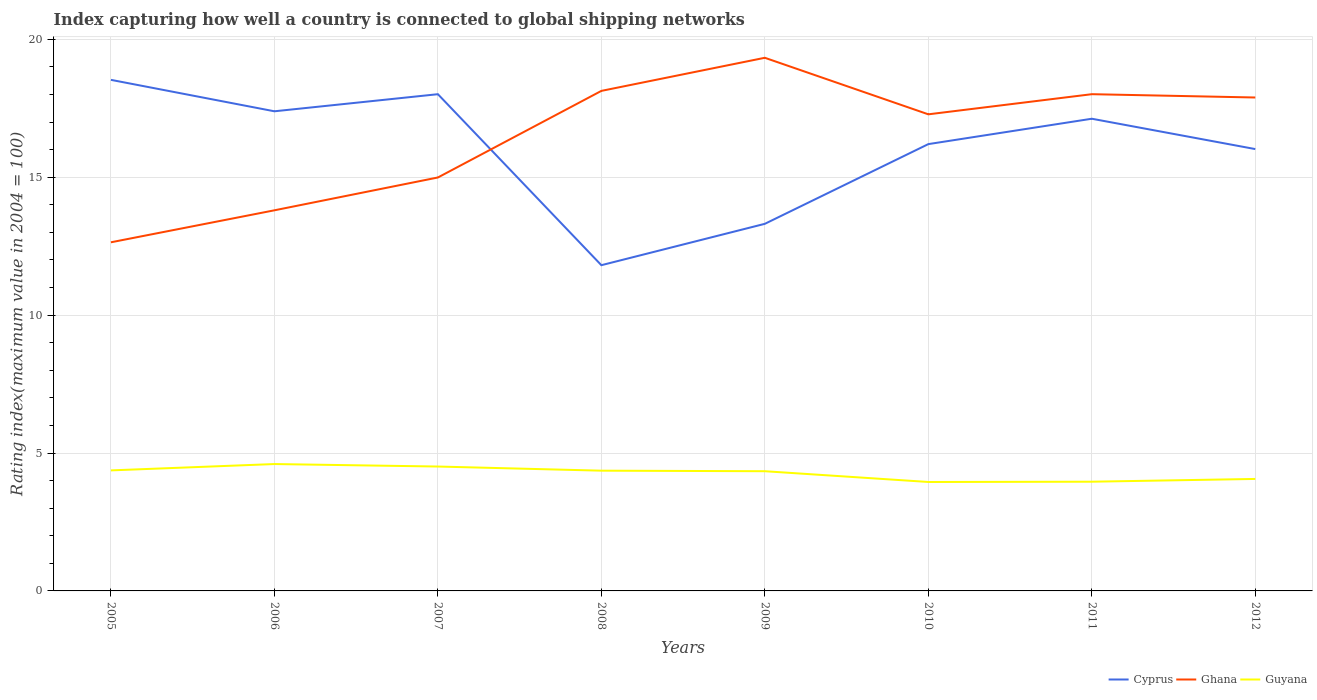How many different coloured lines are there?
Your response must be concise. 3. Does the line corresponding to Guyana intersect with the line corresponding to Ghana?
Give a very brief answer. No. Is the number of lines equal to the number of legend labels?
Your answer should be compact. Yes. Across all years, what is the maximum rating index in Ghana?
Give a very brief answer. 12.64. What is the total rating index in Cyprus in the graph?
Provide a succinct answer. 0.89. What is the difference between the highest and the second highest rating index in Cyprus?
Your response must be concise. 6.72. What is the difference between the highest and the lowest rating index in Guyana?
Your answer should be very brief. 5. How many lines are there?
Your answer should be compact. 3. What is the difference between two consecutive major ticks on the Y-axis?
Ensure brevity in your answer.  5. Are the values on the major ticks of Y-axis written in scientific E-notation?
Give a very brief answer. No. Does the graph contain grids?
Ensure brevity in your answer.  Yes. Where does the legend appear in the graph?
Your answer should be compact. Bottom right. How are the legend labels stacked?
Your answer should be compact. Horizontal. What is the title of the graph?
Your answer should be very brief. Index capturing how well a country is connected to global shipping networks. Does "Azerbaijan" appear as one of the legend labels in the graph?
Ensure brevity in your answer.  No. What is the label or title of the Y-axis?
Provide a succinct answer. Rating index(maximum value in 2004 = 100). What is the Rating index(maximum value in 2004 = 100) of Cyprus in 2005?
Keep it short and to the point. 18.53. What is the Rating index(maximum value in 2004 = 100) of Ghana in 2005?
Make the answer very short. 12.64. What is the Rating index(maximum value in 2004 = 100) in Guyana in 2005?
Make the answer very short. 4.37. What is the Rating index(maximum value in 2004 = 100) in Cyprus in 2006?
Make the answer very short. 17.39. What is the Rating index(maximum value in 2004 = 100) of Ghana in 2006?
Provide a short and direct response. 13.8. What is the Rating index(maximum value in 2004 = 100) of Cyprus in 2007?
Your answer should be very brief. 18.01. What is the Rating index(maximum value in 2004 = 100) in Ghana in 2007?
Give a very brief answer. 14.99. What is the Rating index(maximum value in 2004 = 100) in Guyana in 2007?
Your response must be concise. 4.51. What is the Rating index(maximum value in 2004 = 100) in Cyprus in 2008?
Your response must be concise. 11.81. What is the Rating index(maximum value in 2004 = 100) in Ghana in 2008?
Keep it short and to the point. 18.13. What is the Rating index(maximum value in 2004 = 100) of Guyana in 2008?
Provide a short and direct response. 4.36. What is the Rating index(maximum value in 2004 = 100) of Cyprus in 2009?
Offer a very short reply. 13.31. What is the Rating index(maximum value in 2004 = 100) of Ghana in 2009?
Keep it short and to the point. 19.33. What is the Rating index(maximum value in 2004 = 100) of Guyana in 2009?
Keep it short and to the point. 4.34. What is the Rating index(maximum value in 2004 = 100) in Ghana in 2010?
Your answer should be compact. 17.28. What is the Rating index(maximum value in 2004 = 100) of Guyana in 2010?
Give a very brief answer. 3.95. What is the Rating index(maximum value in 2004 = 100) in Cyprus in 2011?
Give a very brief answer. 17.12. What is the Rating index(maximum value in 2004 = 100) of Ghana in 2011?
Offer a terse response. 18.01. What is the Rating index(maximum value in 2004 = 100) of Guyana in 2011?
Keep it short and to the point. 3.96. What is the Rating index(maximum value in 2004 = 100) in Cyprus in 2012?
Your answer should be very brief. 16.02. What is the Rating index(maximum value in 2004 = 100) of Ghana in 2012?
Give a very brief answer. 17.89. What is the Rating index(maximum value in 2004 = 100) in Guyana in 2012?
Your answer should be very brief. 4.06. Across all years, what is the maximum Rating index(maximum value in 2004 = 100) in Cyprus?
Your answer should be compact. 18.53. Across all years, what is the maximum Rating index(maximum value in 2004 = 100) in Ghana?
Provide a short and direct response. 19.33. Across all years, what is the minimum Rating index(maximum value in 2004 = 100) in Cyprus?
Your answer should be compact. 11.81. Across all years, what is the minimum Rating index(maximum value in 2004 = 100) of Ghana?
Your answer should be compact. 12.64. Across all years, what is the minimum Rating index(maximum value in 2004 = 100) in Guyana?
Provide a short and direct response. 3.95. What is the total Rating index(maximum value in 2004 = 100) in Cyprus in the graph?
Offer a very short reply. 128.39. What is the total Rating index(maximum value in 2004 = 100) in Ghana in the graph?
Your answer should be compact. 132.07. What is the total Rating index(maximum value in 2004 = 100) of Guyana in the graph?
Ensure brevity in your answer.  34.15. What is the difference between the Rating index(maximum value in 2004 = 100) of Cyprus in 2005 and that in 2006?
Your answer should be compact. 1.14. What is the difference between the Rating index(maximum value in 2004 = 100) of Ghana in 2005 and that in 2006?
Your answer should be compact. -1.16. What is the difference between the Rating index(maximum value in 2004 = 100) in Guyana in 2005 and that in 2006?
Your response must be concise. -0.23. What is the difference between the Rating index(maximum value in 2004 = 100) in Cyprus in 2005 and that in 2007?
Give a very brief answer. 0.52. What is the difference between the Rating index(maximum value in 2004 = 100) in Ghana in 2005 and that in 2007?
Ensure brevity in your answer.  -2.35. What is the difference between the Rating index(maximum value in 2004 = 100) of Guyana in 2005 and that in 2007?
Keep it short and to the point. -0.14. What is the difference between the Rating index(maximum value in 2004 = 100) in Cyprus in 2005 and that in 2008?
Provide a short and direct response. 6.72. What is the difference between the Rating index(maximum value in 2004 = 100) in Ghana in 2005 and that in 2008?
Offer a very short reply. -5.49. What is the difference between the Rating index(maximum value in 2004 = 100) of Cyprus in 2005 and that in 2009?
Your answer should be very brief. 5.22. What is the difference between the Rating index(maximum value in 2004 = 100) in Ghana in 2005 and that in 2009?
Offer a very short reply. -6.69. What is the difference between the Rating index(maximum value in 2004 = 100) of Cyprus in 2005 and that in 2010?
Make the answer very short. 2.33. What is the difference between the Rating index(maximum value in 2004 = 100) of Ghana in 2005 and that in 2010?
Make the answer very short. -4.64. What is the difference between the Rating index(maximum value in 2004 = 100) of Guyana in 2005 and that in 2010?
Provide a short and direct response. 0.42. What is the difference between the Rating index(maximum value in 2004 = 100) in Cyprus in 2005 and that in 2011?
Your answer should be compact. 1.41. What is the difference between the Rating index(maximum value in 2004 = 100) in Ghana in 2005 and that in 2011?
Offer a terse response. -5.37. What is the difference between the Rating index(maximum value in 2004 = 100) of Guyana in 2005 and that in 2011?
Your response must be concise. 0.41. What is the difference between the Rating index(maximum value in 2004 = 100) in Cyprus in 2005 and that in 2012?
Make the answer very short. 2.51. What is the difference between the Rating index(maximum value in 2004 = 100) of Ghana in 2005 and that in 2012?
Keep it short and to the point. -5.25. What is the difference between the Rating index(maximum value in 2004 = 100) in Guyana in 2005 and that in 2012?
Provide a succinct answer. 0.31. What is the difference between the Rating index(maximum value in 2004 = 100) in Cyprus in 2006 and that in 2007?
Provide a succinct answer. -0.62. What is the difference between the Rating index(maximum value in 2004 = 100) in Ghana in 2006 and that in 2007?
Make the answer very short. -1.19. What is the difference between the Rating index(maximum value in 2004 = 100) in Guyana in 2006 and that in 2007?
Offer a very short reply. 0.09. What is the difference between the Rating index(maximum value in 2004 = 100) of Cyprus in 2006 and that in 2008?
Offer a terse response. 5.58. What is the difference between the Rating index(maximum value in 2004 = 100) of Ghana in 2006 and that in 2008?
Your response must be concise. -4.33. What is the difference between the Rating index(maximum value in 2004 = 100) in Guyana in 2006 and that in 2008?
Offer a very short reply. 0.24. What is the difference between the Rating index(maximum value in 2004 = 100) of Cyprus in 2006 and that in 2009?
Provide a short and direct response. 4.08. What is the difference between the Rating index(maximum value in 2004 = 100) in Ghana in 2006 and that in 2009?
Keep it short and to the point. -5.53. What is the difference between the Rating index(maximum value in 2004 = 100) in Guyana in 2006 and that in 2009?
Offer a very short reply. 0.26. What is the difference between the Rating index(maximum value in 2004 = 100) of Cyprus in 2006 and that in 2010?
Offer a very short reply. 1.19. What is the difference between the Rating index(maximum value in 2004 = 100) in Ghana in 2006 and that in 2010?
Provide a short and direct response. -3.48. What is the difference between the Rating index(maximum value in 2004 = 100) of Guyana in 2006 and that in 2010?
Offer a very short reply. 0.65. What is the difference between the Rating index(maximum value in 2004 = 100) of Cyprus in 2006 and that in 2011?
Your answer should be compact. 0.27. What is the difference between the Rating index(maximum value in 2004 = 100) of Ghana in 2006 and that in 2011?
Give a very brief answer. -4.21. What is the difference between the Rating index(maximum value in 2004 = 100) in Guyana in 2006 and that in 2011?
Offer a terse response. 0.64. What is the difference between the Rating index(maximum value in 2004 = 100) of Cyprus in 2006 and that in 2012?
Provide a short and direct response. 1.37. What is the difference between the Rating index(maximum value in 2004 = 100) in Ghana in 2006 and that in 2012?
Provide a short and direct response. -4.09. What is the difference between the Rating index(maximum value in 2004 = 100) of Guyana in 2006 and that in 2012?
Keep it short and to the point. 0.54. What is the difference between the Rating index(maximum value in 2004 = 100) of Ghana in 2007 and that in 2008?
Keep it short and to the point. -3.14. What is the difference between the Rating index(maximum value in 2004 = 100) of Cyprus in 2007 and that in 2009?
Keep it short and to the point. 4.7. What is the difference between the Rating index(maximum value in 2004 = 100) in Ghana in 2007 and that in 2009?
Your answer should be compact. -4.34. What is the difference between the Rating index(maximum value in 2004 = 100) in Guyana in 2007 and that in 2009?
Provide a succinct answer. 0.17. What is the difference between the Rating index(maximum value in 2004 = 100) of Cyprus in 2007 and that in 2010?
Make the answer very short. 1.81. What is the difference between the Rating index(maximum value in 2004 = 100) in Ghana in 2007 and that in 2010?
Your answer should be compact. -2.29. What is the difference between the Rating index(maximum value in 2004 = 100) of Guyana in 2007 and that in 2010?
Your answer should be very brief. 0.56. What is the difference between the Rating index(maximum value in 2004 = 100) of Cyprus in 2007 and that in 2011?
Make the answer very short. 0.89. What is the difference between the Rating index(maximum value in 2004 = 100) of Ghana in 2007 and that in 2011?
Ensure brevity in your answer.  -3.02. What is the difference between the Rating index(maximum value in 2004 = 100) of Guyana in 2007 and that in 2011?
Offer a very short reply. 0.55. What is the difference between the Rating index(maximum value in 2004 = 100) of Cyprus in 2007 and that in 2012?
Offer a terse response. 1.99. What is the difference between the Rating index(maximum value in 2004 = 100) in Ghana in 2007 and that in 2012?
Provide a short and direct response. -2.9. What is the difference between the Rating index(maximum value in 2004 = 100) in Guyana in 2007 and that in 2012?
Your answer should be very brief. 0.45. What is the difference between the Rating index(maximum value in 2004 = 100) in Guyana in 2008 and that in 2009?
Provide a succinct answer. 0.02. What is the difference between the Rating index(maximum value in 2004 = 100) of Cyprus in 2008 and that in 2010?
Keep it short and to the point. -4.39. What is the difference between the Rating index(maximum value in 2004 = 100) of Ghana in 2008 and that in 2010?
Give a very brief answer. 0.85. What is the difference between the Rating index(maximum value in 2004 = 100) of Guyana in 2008 and that in 2010?
Give a very brief answer. 0.41. What is the difference between the Rating index(maximum value in 2004 = 100) of Cyprus in 2008 and that in 2011?
Ensure brevity in your answer.  -5.31. What is the difference between the Rating index(maximum value in 2004 = 100) in Ghana in 2008 and that in 2011?
Provide a succinct answer. 0.12. What is the difference between the Rating index(maximum value in 2004 = 100) of Cyprus in 2008 and that in 2012?
Your answer should be compact. -4.21. What is the difference between the Rating index(maximum value in 2004 = 100) in Ghana in 2008 and that in 2012?
Provide a succinct answer. 0.24. What is the difference between the Rating index(maximum value in 2004 = 100) of Cyprus in 2009 and that in 2010?
Offer a terse response. -2.89. What is the difference between the Rating index(maximum value in 2004 = 100) of Ghana in 2009 and that in 2010?
Make the answer very short. 2.05. What is the difference between the Rating index(maximum value in 2004 = 100) of Guyana in 2009 and that in 2010?
Offer a very short reply. 0.39. What is the difference between the Rating index(maximum value in 2004 = 100) of Cyprus in 2009 and that in 2011?
Offer a very short reply. -3.81. What is the difference between the Rating index(maximum value in 2004 = 100) of Ghana in 2009 and that in 2011?
Provide a succinct answer. 1.32. What is the difference between the Rating index(maximum value in 2004 = 100) in Guyana in 2009 and that in 2011?
Offer a terse response. 0.38. What is the difference between the Rating index(maximum value in 2004 = 100) in Cyprus in 2009 and that in 2012?
Ensure brevity in your answer.  -2.71. What is the difference between the Rating index(maximum value in 2004 = 100) of Ghana in 2009 and that in 2012?
Your answer should be very brief. 1.44. What is the difference between the Rating index(maximum value in 2004 = 100) of Guyana in 2009 and that in 2012?
Give a very brief answer. 0.28. What is the difference between the Rating index(maximum value in 2004 = 100) of Cyprus in 2010 and that in 2011?
Your answer should be compact. -0.92. What is the difference between the Rating index(maximum value in 2004 = 100) in Ghana in 2010 and that in 2011?
Provide a short and direct response. -0.73. What is the difference between the Rating index(maximum value in 2004 = 100) of Guyana in 2010 and that in 2011?
Offer a terse response. -0.01. What is the difference between the Rating index(maximum value in 2004 = 100) in Cyprus in 2010 and that in 2012?
Your answer should be very brief. 0.18. What is the difference between the Rating index(maximum value in 2004 = 100) of Ghana in 2010 and that in 2012?
Provide a short and direct response. -0.61. What is the difference between the Rating index(maximum value in 2004 = 100) of Guyana in 2010 and that in 2012?
Your response must be concise. -0.11. What is the difference between the Rating index(maximum value in 2004 = 100) of Ghana in 2011 and that in 2012?
Your answer should be compact. 0.12. What is the difference between the Rating index(maximum value in 2004 = 100) in Guyana in 2011 and that in 2012?
Offer a very short reply. -0.1. What is the difference between the Rating index(maximum value in 2004 = 100) of Cyprus in 2005 and the Rating index(maximum value in 2004 = 100) of Ghana in 2006?
Make the answer very short. 4.73. What is the difference between the Rating index(maximum value in 2004 = 100) in Cyprus in 2005 and the Rating index(maximum value in 2004 = 100) in Guyana in 2006?
Make the answer very short. 13.93. What is the difference between the Rating index(maximum value in 2004 = 100) of Ghana in 2005 and the Rating index(maximum value in 2004 = 100) of Guyana in 2006?
Provide a short and direct response. 8.04. What is the difference between the Rating index(maximum value in 2004 = 100) of Cyprus in 2005 and the Rating index(maximum value in 2004 = 100) of Ghana in 2007?
Give a very brief answer. 3.54. What is the difference between the Rating index(maximum value in 2004 = 100) of Cyprus in 2005 and the Rating index(maximum value in 2004 = 100) of Guyana in 2007?
Provide a short and direct response. 14.02. What is the difference between the Rating index(maximum value in 2004 = 100) of Ghana in 2005 and the Rating index(maximum value in 2004 = 100) of Guyana in 2007?
Keep it short and to the point. 8.13. What is the difference between the Rating index(maximum value in 2004 = 100) in Cyprus in 2005 and the Rating index(maximum value in 2004 = 100) in Ghana in 2008?
Give a very brief answer. 0.4. What is the difference between the Rating index(maximum value in 2004 = 100) of Cyprus in 2005 and the Rating index(maximum value in 2004 = 100) of Guyana in 2008?
Your answer should be compact. 14.17. What is the difference between the Rating index(maximum value in 2004 = 100) in Ghana in 2005 and the Rating index(maximum value in 2004 = 100) in Guyana in 2008?
Offer a very short reply. 8.28. What is the difference between the Rating index(maximum value in 2004 = 100) in Cyprus in 2005 and the Rating index(maximum value in 2004 = 100) in Ghana in 2009?
Your response must be concise. -0.8. What is the difference between the Rating index(maximum value in 2004 = 100) of Cyprus in 2005 and the Rating index(maximum value in 2004 = 100) of Guyana in 2009?
Make the answer very short. 14.19. What is the difference between the Rating index(maximum value in 2004 = 100) in Ghana in 2005 and the Rating index(maximum value in 2004 = 100) in Guyana in 2009?
Your answer should be compact. 8.3. What is the difference between the Rating index(maximum value in 2004 = 100) in Cyprus in 2005 and the Rating index(maximum value in 2004 = 100) in Guyana in 2010?
Offer a terse response. 14.58. What is the difference between the Rating index(maximum value in 2004 = 100) of Ghana in 2005 and the Rating index(maximum value in 2004 = 100) of Guyana in 2010?
Provide a succinct answer. 8.69. What is the difference between the Rating index(maximum value in 2004 = 100) in Cyprus in 2005 and the Rating index(maximum value in 2004 = 100) in Ghana in 2011?
Ensure brevity in your answer.  0.52. What is the difference between the Rating index(maximum value in 2004 = 100) in Cyprus in 2005 and the Rating index(maximum value in 2004 = 100) in Guyana in 2011?
Provide a short and direct response. 14.57. What is the difference between the Rating index(maximum value in 2004 = 100) in Ghana in 2005 and the Rating index(maximum value in 2004 = 100) in Guyana in 2011?
Ensure brevity in your answer.  8.68. What is the difference between the Rating index(maximum value in 2004 = 100) in Cyprus in 2005 and the Rating index(maximum value in 2004 = 100) in Ghana in 2012?
Give a very brief answer. 0.64. What is the difference between the Rating index(maximum value in 2004 = 100) of Cyprus in 2005 and the Rating index(maximum value in 2004 = 100) of Guyana in 2012?
Provide a short and direct response. 14.47. What is the difference between the Rating index(maximum value in 2004 = 100) in Ghana in 2005 and the Rating index(maximum value in 2004 = 100) in Guyana in 2012?
Your response must be concise. 8.58. What is the difference between the Rating index(maximum value in 2004 = 100) of Cyprus in 2006 and the Rating index(maximum value in 2004 = 100) of Guyana in 2007?
Provide a short and direct response. 12.88. What is the difference between the Rating index(maximum value in 2004 = 100) of Ghana in 2006 and the Rating index(maximum value in 2004 = 100) of Guyana in 2007?
Your answer should be very brief. 9.29. What is the difference between the Rating index(maximum value in 2004 = 100) in Cyprus in 2006 and the Rating index(maximum value in 2004 = 100) in Ghana in 2008?
Your response must be concise. -0.74. What is the difference between the Rating index(maximum value in 2004 = 100) of Cyprus in 2006 and the Rating index(maximum value in 2004 = 100) of Guyana in 2008?
Offer a terse response. 13.03. What is the difference between the Rating index(maximum value in 2004 = 100) in Ghana in 2006 and the Rating index(maximum value in 2004 = 100) in Guyana in 2008?
Offer a terse response. 9.44. What is the difference between the Rating index(maximum value in 2004 = 100) in Cyprus in 2006 and the Rating index(maximum value in 2004 = 100) in Ghana in 2009?
Provide a short and direct response. -1.94. What is the difference between the Rating index(maximum value in 2004 = 100) in Cyprus in 2006 and the Rating index(maximum value in 2004 = 100) in Guyana in 2009?
Give a very brief answer. 13.05. What is the difference between the Rating index(maximum value in 2004 = 100) in Ghana in 2006 and the Rating index(maximum value in 2004 = 100) in Guyana in 2009?
Make the answer very short. 9.46. What is the difference between the Rating index(maximum value in 2004 = 100) in Cyprus in 2006 and the Rating index(maximum value in 2004 = 100) in Ghana in 2010?
Your answer should be compact. 0.11. What is the difference between the Rating index(maximum value in 2004 = 100) in Cyprus in 2006 and the Rating index(maximum value in 2004 = 100) in Guyana in 2010?
Make the answer very short. 13.44. What is the difference between the Rating index(maximum value in 2004 = 100) in Ghana in 2006 and the Rating index(maximum value in 2004 = 100) in Guyana in 2010?
Keep it short and to the point. 9.85. What is the difference between the Rating index(maximum value in 2004 = 100) of Cyprus in 2006 and the Rating index(maximum value in 2004 = 100) of Ghana in 2011?
Provide a short and direct response. -0.62. What is the difference between the Rating index(maximum value in 2004 = 100) of Cyprus in 2006 and the Rating index(maximum value in 2004 = 100) of Guyana in 2011?
Provide a short and direct response. 13.43. What is the difference between the Rating index(maximum value in 2004 = 100) in Ghana in 2006 and the Rating index(maximum value in 2004 = 100) in Guyana in 2011?
Ensure brevity in your answer.  9.84. What is the difference between the Rating index(maximum value in 2004 = 100) in Cyprus in 2006 and the Rating index(maximum value in 2004 = 100) in Ghana in 2012?
Provide a short and direct response. -0.5. What is the difference between the Rating index(maximum value in 2004 = 100) in Cyprus in 2006 and the Rating index(maximum value in 2004 = 100) in Guyana in 2012?
Provide a succinct answer. 13.33. What is the difference between the Rating index(maximum value in 2004 = 100) of Ghana in 2006 and the Rating index(maximum value in 2004 = 100) of Guyana in 2012?
Ensure brevity in your answer.  9.74. What is the difference between the Rating index(maximum value in 2004 = 100) in Cyprus in 2007 and the Rating index(maximum value in 2004 = 100) in Ghana in 2008?
Offer a terse response. -0.12. What is the difference between the Rating index(maximum value in 2004 = 100) of Cyprus in 2007 and the Rating index(maximum value in 2004 = 100) of Guyana in 2008?
Offer a very short reply. 13.65. What is the difference between the Rating index(maximum value in 2004 = 100) in Ghana in 2007 and the Rating index(maximum value in 2004 = 100) in Guyana in 2008?
Ensure brevity in your answer.  10.63. What is the difference between the Rating index(maximum value in 2004 = 100) in Cyprus in 2007 and the Rating index(maximum value in 2004 = 100) in Ghana in 2009?
Keep it short and to the point. -1.32. What is the difference between the Rating index(maximum value in 2004 = 100) in Cyprus in 2007 and the Rating index(maximum value in 2004 = 100) in Guyana in 2009?
Make the answer very short. 13.67. What is the difference between the Rating index(maximum value in 2004 = 100) in Ghana in 2007 and the Rating index(maximum value in 2004 = 100) in Guyana in 2009?
Ensure brevity in your answer.  10.65. What is the difference between the Rating index(maximum value in 2004 = 100) in Cyprus in 2007 and the Rating index(maximum value in 2004 = 100) in Ghana in 2010?
Offer a very short reply. 0.73. What is the difference between the Rating index(maximum value in 2004 = 100) of Cyprus in 2007 and the Rating index(maximum value in 2004 = 100) of Guyana in 2010?
Your response must be concise. 14.06. What is the difference between the Rating index(maximum value in 2004 = 100) in Ghana in 2007 and the Rating index(maximum value in 2004 = 100) in Guyana in 2010?
Provide a short and direct response. 11.04. What is the difference between the Rating index(maximum value in 2004 = 100) in Cyprus in 2007 and the Rating index(maximum value in 2004 = 100) in Guyana in 2011?
Provide a short and direct response. 14.05. What is the difference between the Rating index(maximum value in 2004 = 100) of Ghana in 2007 and the Rating index(maximum value in 2004 = 100) of Guyana in 2011?
Ensure brevity in your answer.  11.03. What is the difference between the Rating index(maximum value in 2004 = 100) of Cyprus in 2007 and the Rating index(maximum value in 2004 = 100) of Ghana in 2012?
Ensure brevity in your answer.  0.12. What is the difference between the Rating index(maximum value in 2004 = 100) of Cyprus in 2007 and the Rating index(maximum value in 2004 = 100) of Guyana in 2012?
Your response must be concise. 13.95. What is the difference between the Rating index(maximum value in 2004 = 100) in Ghana in 2007 and the Rating index(maximum value in 2004 = 100) in Guyana in 2012?
Your answer should be very brief. 10.93. What is the difference between the Rating index(maximum value in 2004 = 100) of Cyprus in 2008 and the Rating index(maximum value in 2004 = 100) of Ghana in 2009?
Your answer should be compact. -7.52. What is the difference between the Rating index(maximum value in 2004 = 100) of Cyprus in 2008 and the Rating index(maximum value in 2004 = 100) of Guyana in 2009?
Offer a very short reply. 7.47. What is the difference between the Rating index(maximum value in 2004 = 100) of Ghana in 2008 and the Rating index(maximum value in 2004 = 100) of Guyana in 2009?
Offer a terse response. 13.79. What is the difference between the Rating index(maximum value in 2004 = 100) of Cyprus in 2008 and the Rating index(maximum value in 2004 = 100) of Ghana in 2010?
Keep it short and to the point. -5.47. What is the difference between the Rating index(maximum value in 2004 = 100) in Cyprus in 2008 and the Rating index(maximum value in 2004 = 100) in Guyana in 2010?
Keep it short and to the point. 7.86. What is the difference between the Rating index(maximum value in 2004 = 100) in Ghana in 2008 and the Rating index(maximum value in 2004 = 100) in Guyana in 2010?
Ensure brevity in your answer.  14.18. What is the difference between the Rating index(maximum value in 2004 = 100) in Cyprus in 2008 and the Rating index(maximum value in 2004 = 100) in Ghana in 2011?
Your response must be concise. -6.2. What is the difference between the Rating index(maximum value in 2004 = 100) in Cyprus in 2008 and the Rating index(maximum value in 2004 = 100) in Guyana in 2011?
Your answer should be compact. 7.85. What is the difference between the Rating index(maximum value in 2004 = 100) of Ghana in 2008 and the Rating index(maximum value in 2004 = 100) of Guyana in 2011?
Your answer should be very brief. 14.17. What is the difference between the Rating index(maximum value in 2004 = 100) of Cyprus in 2008 and the Rating index(maximum value in 2004 = 100) of Ghana in 2012?
Your answer should be compact. -6.08. What is the difference between the Rating index(maximum value in 2004 = 100) of Cyprus in 2008 and the Rating index(maximum value in 2004 = 100) of Guyana in 2012?
Provide a short and direct response. 7.75. What is the difference between the Rating index(maximum value in 2004 = 100) in Ghana in 2008 and the Rating index(maximum value in 2004 = 100) in Guyana in 2012?
Provide a short and direct response. 14.07. What is the difference between the Rating index(maximum value in 2004 = 100) in Cyprus in 2009 and the Rating index(maximum value in 2004 = 100) in Ghana in 2010?
Your response must be concise. -3.97. What is the difference between the Rating index(maximum value in 2004 = 100) in Cyprus in 2009 and the Rating index(maximum value in 2004 = 100) in Guyana in 2010?
Give a very brief answer. 9.36. What is the difference between the Rating index(maximum value in 2004 = 100) of Ghana in 2009 and the Rating index(maximum value in 2004 = 100) of Guyana in 2010?
Offer a terse response. 15.38. What is the difference between the Rating index(maximum value in 2004 = 100) of Cyprus in 2009 and the Rating index(maximum value in 2004 = 100) of Ghana in 2011?
Keep it short and to the point. -4.7. What is the difference between the Rating index(maximum value in 2004 = 100) of Cyprus in 2009 and the Rating index(maximum value in 2004 = 100) of Guyana in 2011?
Keep it short and to the point. 9.35. What is the difference between the Rating index(maximum value in 2004 = 100) of Ghana in 2009 and the Rating index(maximum value in 2004 = 100) of Guyana in 2011?
Ensure brevity in your answer.  15.37. What is the difference between the Rating index(maximum value in 2004 = 100) of Cyprus in 2009 and the Rating index(maximum value in 2004 = 100) of Ghana in 2012?
Your answer should be compact. -4.58. What is the difference between the Rating index(maximum value in 2004 = 100) of Cyprus in 2009 and the Rating index(maximum value in 2004 = 100) of Guyana in 2012?
Ensure brevity in your answer.  9.25. What is the difference between the Rating index(maximum value in 2004 = 100) of Ghana in 2009 and the Rating index(maximum value in 2004 = 100) of Guyana in 2012?
Offer a very short reply. 15.27. What is the difference between the Rating index(maximum value in 2004 = 100) in Cyprus in 2010 and the Rating index(maximum value in 2004 = 100) in Ghana in 2011?
Your answer should be compact. -1.81. What is the difference between the Rating index(maximum value in 2004 = 100) of Cyprus in 2010 and the Rating index(maximum value in 2004 = 100) of Guyana in 2011?
Give a very brief answer. 12.24. What is the difference between the Rating index(maximum value in 2004 = 100) in Ghana in 2010 and the Rating index(maximum value in 2004 = 100) in Guyana in 2011?
Keep it short and to the point. 13.32. What is the difference between the Rating index(maximum value in 2004 = 100) in Cyprus in 2010 and the Rating index(maximum value in 2004 = 100) in Ghana in 2012?
Your answer should be compact. -1.69. What is the difference between the Rating index(maximum value in 2004 = 100) in Cyprus in 2010 and the Rating index(maximum value in 2004 = 100) in Guyana in 2012?
Make the answer very short. 12.14. What is the difference between the Rating index(maximum value in 2004 = 100) of Ghana in 2010 and the Rating index(maximum value in 2004 = 100) of Guyana in 2012?
Ensure brevity in your answer.  13.22. What is the difference between the Rating index(maximum value in 2004 = 100) of Cyprus in 2011 and the Rating index(maximum value in 2004 = 100) of Ghana in 2012?
Offer a terse response. -0.77. What is the difference between the Rating index(maximum value in 2004 = 100) of Cyprus in 2011 and the Rating index(maximum value in 2004 = 100) of Guyana in 2012?
Offer a terse response. 13.06. What is the difference between the Rating index(maximum value in 2004 = 100) in Ghana in 2011 and the Rating index(maximum value in 2004 = 100) in Guyana in 2012?
Your answer should be very brief. 13.95. What is the average Rating index(maximum value in 2004 = 100) in Cyprus per year?
Provide a succinct answer. 16.05. What is the average Rating index(maximum value in 2004 = 100) in Ghana per year?
Make the answer very short. 16.51. What is the average Rating index(maximum value in 2004 = 100) in Guyana per year?
Give a very brief answer. 4.27. In the year 2005, what is the difference between the Rating index(maximum value in 2004 = 100) in Cyprus and Rating index(maximum value in 2004 = 100) in Ghana?
Your response must be concise. 5.89. In the year 2005, what is the difference between the Rating index(maximum value in 2004 = 100) of Cyprus and Rating index(maximum value in 2004 = 100) of Guyana?
Your answer should be compact. 14.16. In the year 2005, what is the difference between the Rating index(maximum value in 2004 = 100) of Ghana and Rating index(maximum value in 2004 = 100) of Guyana?
Your answer should be compact. 8.27. In the year 2006, what is the difference between the Rating index(maximum value in 2004 = 100) in Cyprus and Rating index(maximum value in 2004 = 100) in Ghana?
Your response must be concise. 3.59. In the year 2006, what is the difference between the Rating index(maximum value in 2004 = 100) of Cyprus and Rating index(maximum value in 2004 = 100) of Guyana?
Provide a succinct answer. 12.79. In the year 2007, what is the difference between the Rating index(maximum value in 2004 = 100) in Cyprus and Rating index(maximum value in 2004 = 100) in Ghana?
Offer a terse response. 3.02. In the year 2007, what is the difference between the Rating index(maximum value in 2004 = 100) in Cyprus and Rating index(maximum value in 2004 = 100) in Guyana?
Your response must be concise. 13.5. In the year 2007, what is the difference between the Rating index(maximum value in 2004 = 100) of Ghana and Rating index(maximum value in 2004 = 100) of Guyana?
Make the answer very short. 10.48. In the year 2008, what is the difference between the Rating index(maximum value in 2004 = 100) in Cyprus and Rating index(maximum value in 2004 = 100) in Ghana?
Your answer should be very brief. -6.32. In the year 2008, what is the difference between the Rating index(maximum value in 2004 = 100) in Cyprus and Rating index(maximum value in 2004 = 100) in Guyana?
Keep it short and to the point. 7.45. In the year 2008, what is the difference between the Rating index(maximum value in 2004 = 100) of Ghana and Rating index(maximum value in 2004 = 100) of Guyana?
Your answer should be very brief. 13.77. In the year 2009, what is the difference between the Rating index(maximum value in 2004 = 100) of Cyprus and Rating index(maximum value in 2004 = 100) of Ghana?
Make the answer very short. -6.02. In the year 2009, what is the difference between the Rating index(maximum value in 2004 = 100) of Cyprus and Rating index(maximum value in 2004 = 100) of Guyana?
Make the answer very short. 8.97. In the year 2009, what is the difference between the Rating index(maximum value in 2004 = 100) of Ghana and Rating index(maximum value in 2004 = 100) of Guyana?
Provide a succinct answer. 14.99. In the year 2010, what is the difference between the Rating index(maximum value in 2004 = 100) in Cyprus and Rating index(maximum value in 2004 = 100) in Ghana?
Your response must be concise. -1.08. In the year 2010, what is the difference between the Rating index(maximum value in 2004 = 100) in Cyprus and Rating index(maximum value in 2004 = 100) in Guyana?
Your response must be concise. 12.25. In the year 2010, what is the difference between the Rating index(maximum value in 2004 = 100) in Ghana and Rating index(maximum value in 2004 = 100) in Guyana?
Your response must be concise. 13.33. In the year 2011, what is the difference between the Rating index(maximum value in 2004 = 100) in Cyprus and Rating index(maximum value in 2004 = 100) in Ghana?
Give a very brief answer. -0.89. In the year 2011, what is the difference between the Rating index(maximum value in 2004 = 100) in Cyprus and Rating index(maximum value in 2004 = 100) in Guyana?
Offer a very short reply. 13.16. In the year 2011, what is the difference between the Rating index(maximum value in 2004 = 100) in Ghana and Rating index(maximum value in 2004 = 100) in Guyana?
Your response must be concise. 14.05. In the year 2012, what is the difference between the Rating index(maximum value in 2004 = 100) in Cyprus and Rating index(maximum value in 2004 = 100) in Ghana?
Your response must be concise. -1.87. In the year 2012, what is the difference between the Rating index(maximum value in 2004 = 100) in Cyprus and Rating index(maximum value in 2004 = 100) in Guyana?
Offer a very short reply. 11.96. In the year 2012, what is the difference between the Rating index(maximum value in 2004 = 100) of Ghana and Rating index(maximum value in 2004 = 100) of Guyana?
Your answer should be compact. 13.83. What is the ratio of the Rating index(maximum value in 2004 = 100) in Cyprus in 2005 to that in 2006?
Ensure brevity in your answer.  1.07. What is the ratio of the Rating index(maximum value in 2004 = 100) in Ghana in 2005 to that in 2006?
Keep it short and to the point. 0.92. What is the ratio of the Rating index(maximum value in 2004 = 100) in Guyana in 2005 to that in 2006?
Ensure brevity in your answer.  0.95. What is the ratio of the Rating index(maximum value in 2004 = 100) of Cyprus in 2005 to that in 2007?
Give a very brief answer. 1.03. What is the ratio of the Rating index(maximum value in 2004 = 100) of Ghana in 2005 to that in 2007?
Ensure brevity in your answer.  0.84. What is the ratio of the Rating index(maximum value in 2004 = 100) in Cyprus in 2005 to that in 2008?
Provide a succinct answer. 1.57. What is the ratio of the Rating index(maximum value in 2004 = 100) in Ghana in 2005 to that in 2008?
Offer a very short reply. 0.7. What is the ratio of the Rating index(maximum value in 2004 = 100) in Guyana in 2005 to that in 2008?
Give a very brief answer. 1. What is the ratio of the Rating index(maximum value in 2004 = 100) in Cyprus in 2005 to that in 2009?
Keep it short and to the point. 1.39. What is the ratio of the Rating index(maximum value in 2004 = 100) of Ghana in 2005 to that in 2009?
Offer a very short reply. 0.65. What is the ratio of the Rating index(maximum value in 2004 = 100) in Guyana in 2005 to that in 2009?
Ensure brevity in your answer.  1.01. What is the ratio of the Rating index(maximum value in 2004 = 100) in Cyprus in 2005 to that in 2010?
Keep it short and to the point. 1.14. What is the ratio of the Rating index(maximum value in 2004 = 100) in Ghana in 2005 to that in 2010?
Make the answer very short. 0.73. What is the ratio of the Rating index(maximum value in 2004 = 100) in Guyana in 2005 to that in 2010?
Your response must be concise. 1.11. What is the ratio of the Rating index(maximum value in 2004 = 100) of Cyprus in 2005 to that in 2011?
Your answer should be compact. 1.08. What is the ratio of the Rating index(maximum value in 2004 = 100) of Ghana in 2005 to that in 2011?
Keep it short and to the point. 0.7. What is the ratio of the Rating index(maximum value in 2004 = 100) in Guyana in 2005 to that in 2011?
Make the answer very short. 1.1. What is the ratio of the Rating index(maximum value in 2004 = 100) in Cyprus in 2005 to that in 2012?
Give a very brief answer. 1.16. What is the ratio of the Rating index(maximum value in 2004 = 100) of Ghana in 2005 to that in 2012?
Provide a succinct answer. 0.71. What is the ratio of the Rating index(maximum value in 2004 = 100) in Guyana in 2005 to that in 2012?
Ensure brevity in your answer.  1.08. What is the ratio of the Rating index(maximum value in 2004 = 100) in Cyprus in 2006 to that in 2007?
Provide a succinct answer. 0.97. What is the ratio of the Rating index(maximum value in 2004 = 100) of Ghana in 2006 to that in 2007?
Ensure brevity in your answer.  0.92. What is the ratio of the Rating index(maximum value in 2004 = 100) in Guyana in 2006 to that in 2007?
Your answer should be very brief. 1.02. What is the ratio of the Rating index(maximum value in 2004 = 100) of Cyprus in 2006 to that in 2008?
Your response must be concise. 1.47. What is the ratio of the Rating index(maximum value in 2004 = 100) in Ghana in 2006 to that in 2008?
Offer a terse response. 0.76. What is the ratio of the Rating index(maximum value in 2004 = 100) in Guyana in 2006 to that in 2008?
Your answer should be compact. 1.05. What is the ratio of the Rating index(maximum value in 2004 = 100) of Cyprus in 2006 to that in 2009?
Give a very brief answer. 1.31. What is the ratio of the Rating index(maximum value in 2004 = 100) in Ghana in 2006 to that in 2009?
Offer a terse response. 0.71. What is the ratio of the Rating index(maximum value in 2004 = 100) in Guyana in 2006 to that in 2009?
Your answer should be compact. 1.06. What is the ratio of the Rating index(maximum value in 2004 = 100) of Cyprus in 2006 to that in 2010?
Your answer should be compact. 1.07. What is the ratio of the Rating index(maximum value in 2004 = 100) in Ghana in 2006 to that in 2010?
Provide a short and direct response. 0.8. What is the ratio of the Rating index(maximum value in 2004 = 100) in Guyana in 2006 to that in 2010?
Keep it short and to the point. 1.16. What is the ratio of the Rating index(maximum value in 2004 = 100) in Cyprus in 2006 to that in 2011?
Provide a succinct answer. 1.02. What is the ratio of the Rating index(maximum value in 2004 = 100) in Ghana in 2006 to that in 2011?
Your answer should be very brief. 0.77. What is the ratio of the Rating index(maximum value in 2004 = 100) in Guyana in 2006 to that in 2011?
Ensure brevity in your answer.  1.16. What is the ratio of the Rating index(maximum value in 2004 = 100) in Cyprus in 2006 to that in 2012?
Give a very brief answer. 1.09. What is the ratio of the Rating index(maximum value in 2004 = 100) in Ghana in 2006 to that in 2012?
Keep it short and to the point. 0.77. What is the ratio of the Rating index(maximum value in 2004 = 100) of Guyana in 2006 to that in 2012?
Your answer should be very brief. 1.13. What is the ratio of the Rating index(maximum value in 2004 = 100) of Cyprus in 2007 to that in 2008?
Keep it short and to the point. 1.52. What is the ratio of the Rating index(maximum value in 2004 = 100) of Ghana in 2007 to that in 2008?
Give a very brief answer. 0.83. What is the ratio of the Rating index(maximum value in 2004 = 100) in Guyana in 2007 to that in 2008?
Make the answer very short. 1.03. What is the ratio of the Rating index(maximum value in 2004 = 100) in Cyprus in 2007 to that in 2009?
Your answer should be compact. 1.35. What is the ratio of the Rating index(maximum value in 2004 = 100) of Ghana in 2007 to that in 2009?
Your response must be concise. 0.78. What is the ratio of the Rating index(maximum value in 2004 = 100) of Guyana in 2007 to that in 2009?
Provide a succinct answer. 1.04. What is the ratio of the Rating index(maximum value in 2004 = 100) of Cyprus in 2007 to that in 2010?
Make the answer very short. 1.11. What is the ratio of the Rating index(maximum value in 2004 = 100) of Ghana in 2007 to that in 2010?
Offer a terse response. 0.87. What is the ratio of the Rating index(maximum value in 2004 = 100) in Guyana in 2007 to that in 2010?
Keep it short and to the point. 1.14. What is the ratio of the Rating index(maximum value in 2004 = 100) of Cyprus in 2007 to that in 2011?
Keep it short and to the point. 1.05. What is the ratio of the Rating index(maximum value in 2004 = 100) in Ghana in 2007 to that in 2011?
Keep it short and to the point. 0.83. What is the ratio of the Rating index(maximum value in 2004 = 100) in Guyana in 2007 to that in 2011?
Your answer should be compact. 1.14. What is the ratio of the Rating index(maximum value in 2004 = 100) in Cyprus in 2007 to that in 2012?
Make the answer very short. 1.12. What is the ratio of the Rating index(maximum value in 2004 = 100) in Ghana in 2007 to that in 2012?
Your answer should be compact. 0.84. What is the ratio of the Rating index(maximum value in 2004 = 100) of Guyana in 2007 to that in 2012?
Provide a succinct answer. 1.11. What is the ratio of the Rating index(maximum value in 2004 = 100) of Cyprus in 2008 to that in 2009?
Offer a terse response. 0.89. What is the ratio of the Rating index(maximum value in 2004 = 100) in Ghana in 2008 to that in 2009?
Your answer should be compact. 0.94. What is the ratio of the Rating index(maximum value in 2004 = 100) in Guyana in 2008 to that in 2009?
Give a very brief answer. 1. What is the ratio of the Rating index(maximum value in 2004 = 100) of Cyprus in 2008 to that in 2010?
Your answer should be compact. 0.73. What is the ratio of the Rating index(maximum value in 2004 = 100) in Ghana in 2008 to that in 2010?
Offer a terse response. 1.05. What is the ratio of the Rating index(maximum value in 2004 = 100) in Guyana in 2008 to that in 2010?
Your answer should be compact. 1.1. What is the ratio of the Rating index(maximum value in 2004 = 100) in Cyprus in 2008 to that in 2011?
Provide a succinct answer. 0.69. What is the ratio of the Rating index(maximum value in 2004 = 100) of Ghana in 2008 to that in 2011?
Give a very brief answer. 1.01. What is the ratio of the Rating index(maximum value in 2004 = 100) of Guyana in 2008 to that in 2011?
Your answer should be very brief. 1.1. What is the ratio of the Rating index(maximum value in 2004 = 100) of Cyprus in 2008 to that in 2012?
Make the answer very short. 0.74. What is the ratio of the Rating index(maximum value in 2004 = 100) in Ghana in 2008 to that in 2012?
Your response must be concise. 1.01. What is the ratio of the Rating index(maximum value in 2004 = 100) in Guyana in 2008 to that in 2012?
Your answer should be very brief. 1.07. What is the ratio of the Rating index(maximum value in 2004 = 100) of Cyprus in 2009 to that in 2010?
Keep it short and to the point. 0.82. What is the ratio of the Rating index(maximum value in 2004 = 100) in Ghana in 2009 to that in 2010?
Keep it short and to the point. 1.12. What is the ratio of the Rating index(maximum value in 2004 = 100) of Guyana in 2009 to that in 2010?
Offer a terse response. 1.1. What is the ratio of the Rating index(maximum value in 2004 = 100) of Cyprus in 2009 to that in 2011?
Your response must be concise. 0.78. What is the ratio of the Rating index(maximum value in 2004 = 100) in Ghana in 2009 to that in 2011?
Offer a very short reply. 1.07. What is the ratio of the Rating index(maximum value in 2004 = 100) in Guyana in 2009 to that in 2011?
Make the answer very short. 1.1. What is the ratio of the Rating index(maximum value in 2004 = 100) in Cyprus in 2009 to that in 2012?
Provide a succinct answer. 0.83. What is the ratio of the Rating index(maximum value in 2004 = 100) of Ghana in 2009 to that in 2012?
Make the answer very short. 1.08. What is the ratio of the Rating index(maximum value in 2004 = 100) of Guyana in 2009 to that in 2012?
Offer a very short reply. 1.07. What is the ratio of the Rating index(maximum value in 2004 = 100) in Cyprus in 2010 to that in 2011?
Keep it short and to the point. 0.95. What is the ratio of the Rating index(maximum value in 2004 = 100) of Ghana in 2010 to that in 2011?
Your answer should be very brief. 0.96. What is the ratio of the Rating index(maximum value in 2004 = 100) of Guyana in 2010 to that in 2011?
Ensure brevity in your answer.  1. What is the ratio of the Rating index(maximum value in 2004 = 100) in Cyprus in 2010 to that in 2012?
Provide a succinct answer. 1.01. What is the ratio of the Rating index(maximum value in 2004 = 100) in Ghana in 2010 to that in 2012?
Your response must be concise. 0.97. What is the ratio of the Rating index(maximum value in 2004 = 100) of Guyana in 2010 to that in 2012?
Your answer should be very brief. 0.97. What is the ratio of the Rating index(maximum value in 2004 = 100) in Cyprus in 2011 to that in 2012?
Your answer should be compact. 1.07. What is the ratio of the Rating index(maximum value in 2004 = 100) in Ghana in 2011 to that in 2012?
Ensure brevity in your answer.  1.01. What is the ratio of the Rating index(maximum value in 2004 = 100) in Guyana in 2011 to that in 2012?
Your answer should be compact. 0.98. What is the difference between the highest and the second highest Rating index(maximum value in 2004 = 100) in Cyprus?
Your response must be concise. 0.52. What is the difference between the highest and the second highest Rating index(maximum value in 2004 = 100) of Guyana?
Your response must be concise. 0.09. What is the difference between the highest and the lowest Rating index(maximum value in 2004 = 100) in Cyprus?
Provide a succinct answer. 6.72. What is the difference between the highest and the lowest Rating index(maximum value in 2004 = 100) in Ghana?
Make the answer very short. 6.69. What is the difference between the highest and the lowest Rating index(maximum value in 2004 = 100) of Guyana?
Provide a short and direct response. 0.65. 